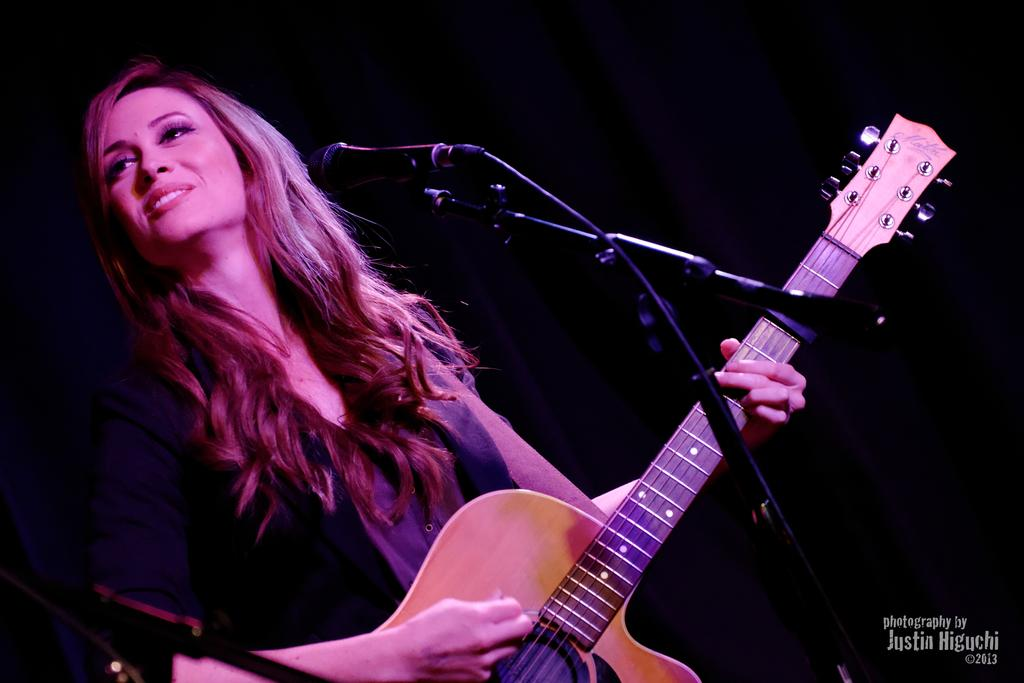Who is the main subject in the image? There is a woman in the image. What is the woman doing in the image? The woman is standing and playing a guitar. What object is in front of the woman? There is a microphone in front of the woman. How does the woman appear to feel in the image? The woman is smiling in the image. Where is the girl sitting on the swing in the image? There is no girl or swing present in the image; it features a woman playing a guitar and standing near a microphone. What type of table is visible in the image? There is no table visible in the image. 